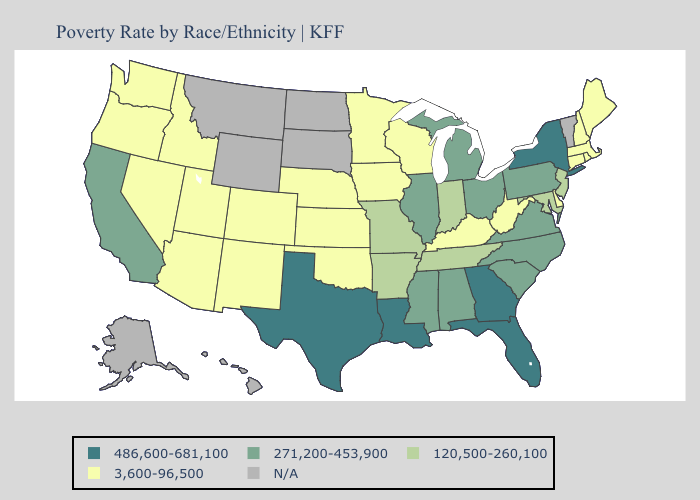Among the states that border New Mexico , does Texas have the highest value?
Keep it brief. Yes. What is the highest value in states that border West Virginia?
Be succinct. 271,200-453,900. Does Wisconsin have the highest value in the MidWest?
Keep it brief. No. Which states have the lowest value in the Northeast?
Short answer required. Connecticut, Maine, Massachusetts, New Hampshire, Rhode Island. Name the states that have a value in the range 271,200-453,900?
Answer briefly. Alabama, California, Illinois, Michigan, Mississippi, North Carolina, Ohio, Pennsylvania, South Carolina, Virginia. How many symbols are there in the legend?
Write a very short answer. 5. How many symbols are there in the legend?
Concise answer only. 5. What is the lowest value in the USA?
Short answer required. 3,600-96,500. Name the states that have a value in the range N/A?
Keep it brief. Alaska, Hawaii, Montana, North Dakota, South Dakota, Vermont, Wyoming. Which states have the highest value in the USA?
Keep it brief. Florida, Georgia, Louisiana, New York, Texas. Name the states that have a value in the range 120,500-260,100?
Short answer required. Arkansas, Indiana, Maryland, Missouri, New Jersey, Tennessee. Does Oklahoma have the lowest value in the South?
Answer briefly. Yes. Name the states that have a value in the range 3,600-96,500?
Give a very brief answer. Arizona, Colorado, Connecticut, Delaware, Idaho, Iowa, Kansas, Kentucky, Maine, Massachusetts, Minnesota, Nebraska, Nevada, New Hampshire, New Mexico, Oklahoma, Oregon, Rhode Island, Utah, Washington, West Virginia, Wisconsin. Does Florida have the highest value in the USA?
Concise answer only. Yes. 